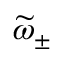<formula> <loc_0><loc_0><loc_500><loc_500>\widetilde { \omega } _ { \pm }</formula> 